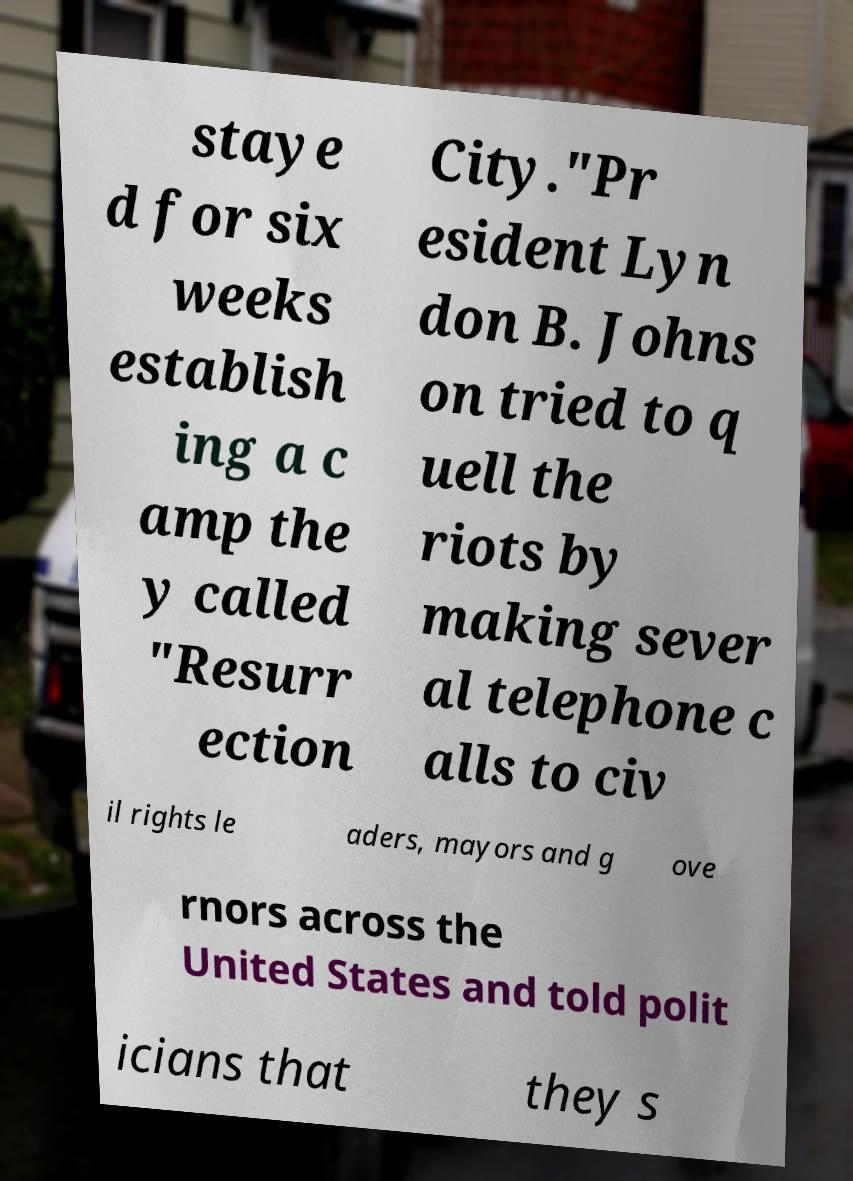Please read and relay the text visible in this image. What does it say? staye d for six weeks establish ing a c amp the y called "Resurr ection City."Pr esident Lyn don B. Johns on tried to q uell the riots by making sever al telephone c alls to civ il rights le aders, mayors and g ove rnors across the United States and told polit icians that they s 